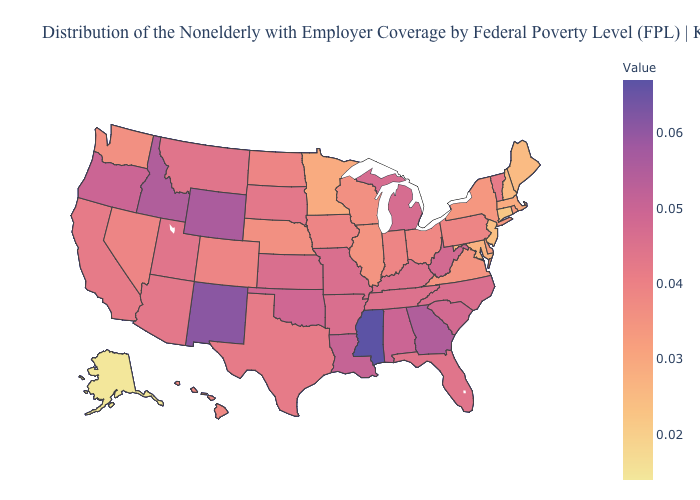Which states have the lowest value in the USA?
Be succinct. Alaska. Which states hav the highest value in the West?
Answer briefly. New Mexico. Which states have the lowest value in the USA?
Short answer required. Alaska. Does Georgia have a lower value than Mississippi?
Quick response, please. Yes. 